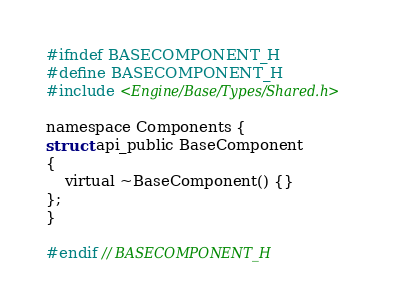<code> <loc_0><loc_0><loc_500><loc_500><_C_>#ifndef BASECOMPONENT_H
#define BASECOMPONENT_H
#include <Engine/Base/Types/Shared.h>

namespace Components {
struct api_public BaseComponent
{
    virtual ~BaseComponent() {}
};
}

#endif // BASECOMPONENT_H
</code> 